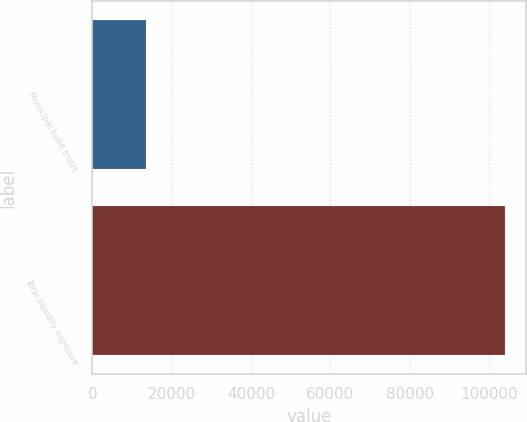Convert chart. <chart><loc_0><loc_0><loc_500><loc_500><bar_chart><fcel>Municipal bond trusts<fcel>Total liquidity exposure<nl><fcel>13467<fcel>104061<nl></chart> 